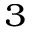Convert formula to latex. <formula><loc_0><loc_0><loc_500><loc_500>^ { 3 }</formula> 